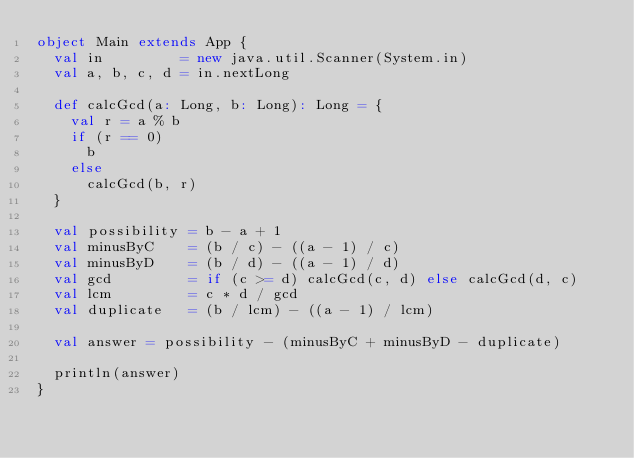Convert code to text. <code><loc_0><loc_0><loc_500><loc_500><_Scala_>object Main extends App {
  val in         = new java.util.Scanner(System.in)
  val a, b, c, d = in.nextLong

  def calcGcd(a: Long, b: Long): Long = {
    val r = a % b
    if (r == 0)
      b
    else
      calcGcd(b, r)
  }

  val possibility = b - a + 1
  val minusByC    = (b / c) - ((a - 1) / c)
  val minusByD    = (b / d) - ((a - 1) / d)
  val gcd         = if (c >= d) calcGcd(c, d) else calcGcd(d, c)
  val lcm         = c * d / gcd
  val duplicate   = (b / lcm) - ((a - 1) / lcm)

  val answer = possibility - (minusByC + minusByD - duplicate)

  println(answer)
}
</code> 